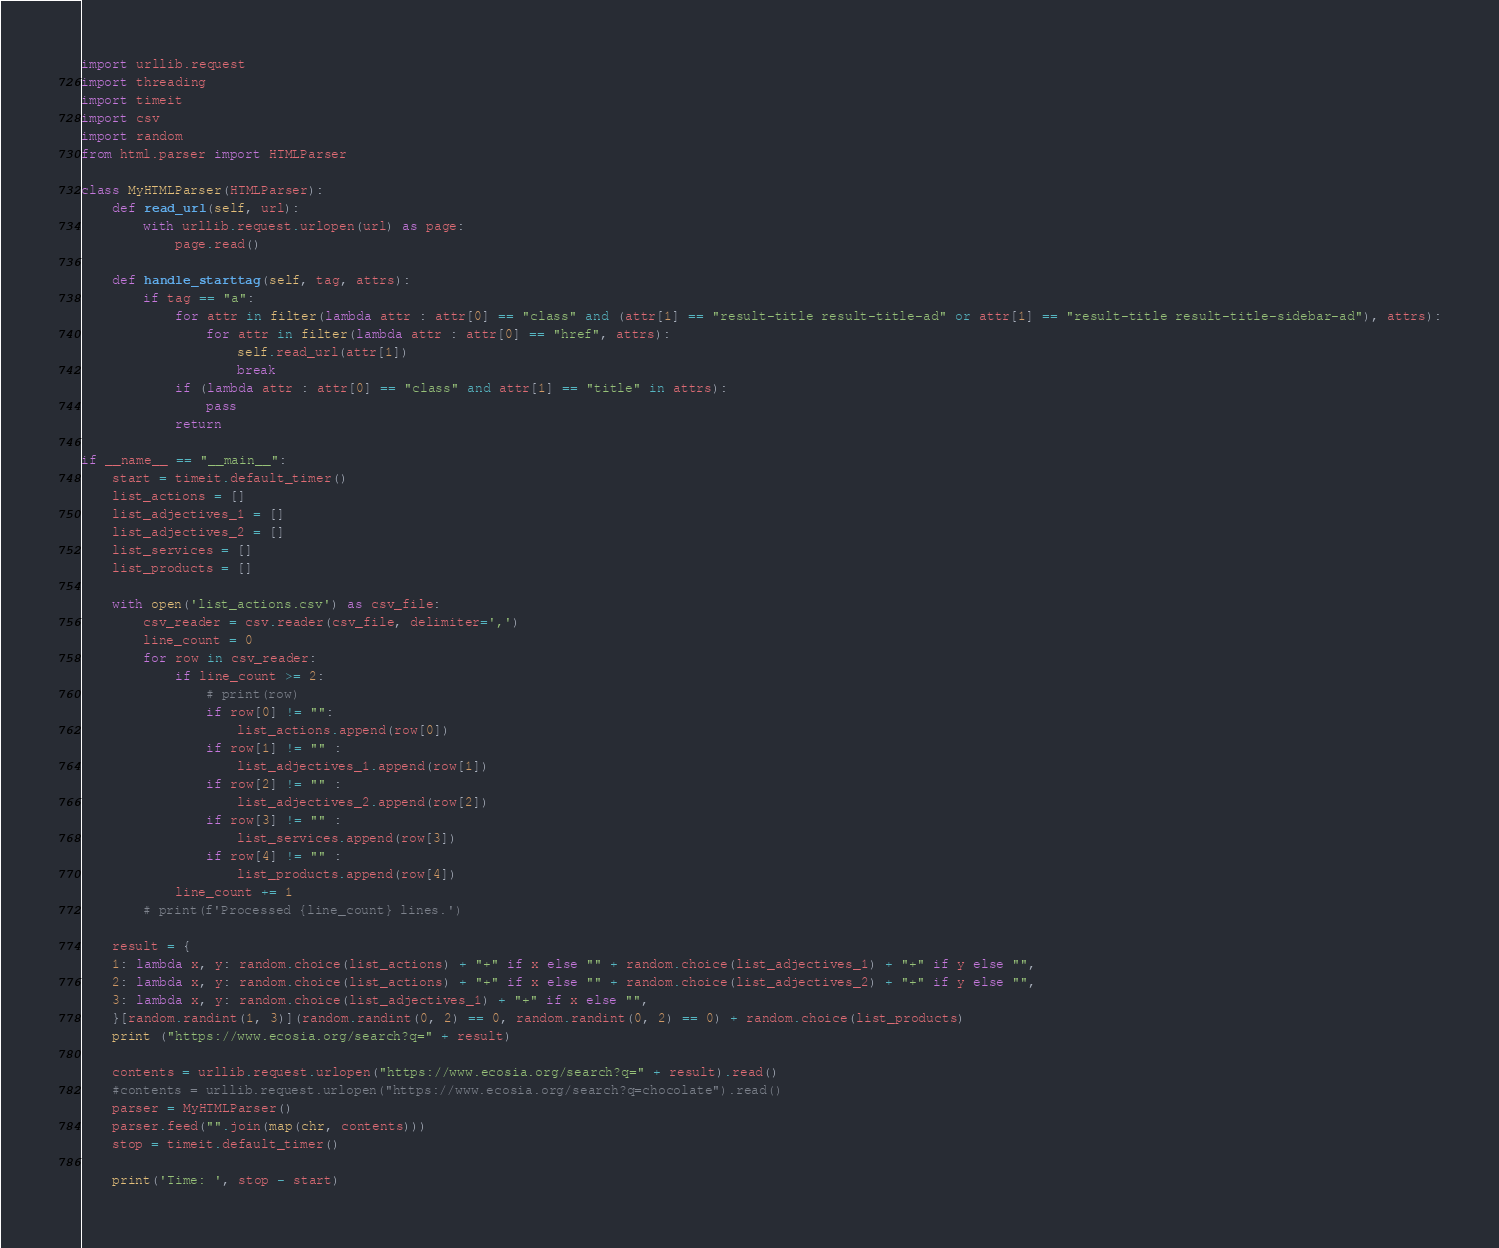<code> <loc_0><loc_0><loc_500><loc_500><_Python_>import urllib.request
import threading
import timeit
import csv
import random
from html.parser import HTMLParser

class MyHTMLParser(HTMLParser):
    def read_url(self, url):
        with urllib.request.urlopen(url) as page:
            page.read()

    def handle_starttag(self, tag, attrs):
        if tag == "a":
            for attr in filter(lambda attr : attr[0] == "class" and (attr[1] == "result-title result-title-ad" or attr[1] == "result-title result-title-sidebar-ad"), attrs):
                for attr in filter(lambda attr : attr[0] == "href", attrs):
                    self.read_url(attr[1])
                    break
            if (lambda attr : attr[0] == "class" and attr[1] == "title" in attrs):
                pass
            return

if __name__ == "__main__":
    start = timeit.default_timer()
    list_actions = []
    list_adjectives_1 = []
    list_adjectives_2 = []
    list_services = []
    list_products = []

    with open('list_actions.csv') as csv_file:
        csv_reader = csv.reader(csv_file, delimiter=',')
        line_count = 0
        for row in csv_reader:
            if line_count >= 2:
                # print(row)
                if row[0] != "":
                    list_actions.append(row[0])
                if row[1] != "" :
                    list_adjectives_1.append(row[1])
                if row[2] != "" :
                    list_adjectives_2.append(row[2])
                if row[3] != "" :
                    list_services.append(row[3])
                if row[4] != "" :
                    list_products.append(row[4])
            line_count += 1
        # print(f'Processed {line_count} lines.')

    result = {
    1: lambda x, y: random.choice(list_actions) + "+" if x else "" + random.choice(list_adjectives_1) + "+" if y else "",
    2: lambda x, y: random.choice(list_actions) + "+" if x else "" + random.choice(list_adjectives_2) + "+" if y else "",
    3: lambda x, y: random.choice(list_adjectives_1) + "+" if x else "",
    }[random.randint(1, 3)](random.randint(0, 2) == 0, random.randint(0, 2) == 0) + random.choice(list_products)
    print ("https://www.ecosia.org/search?q=" + result) 

    contents = urllib.request.urlopen("https://www.ecosia.org/search?q=" + result).read()
    #contents = urllib.request.urlopen("https://www.ecosia.org/search?q=chocolate").read()
    parser = MyHTMLParser()
    parser.feed("".join(map(chr, contents)))
    stop = timeit.default_timer()

    print('Time: ', stop - start)</code> 